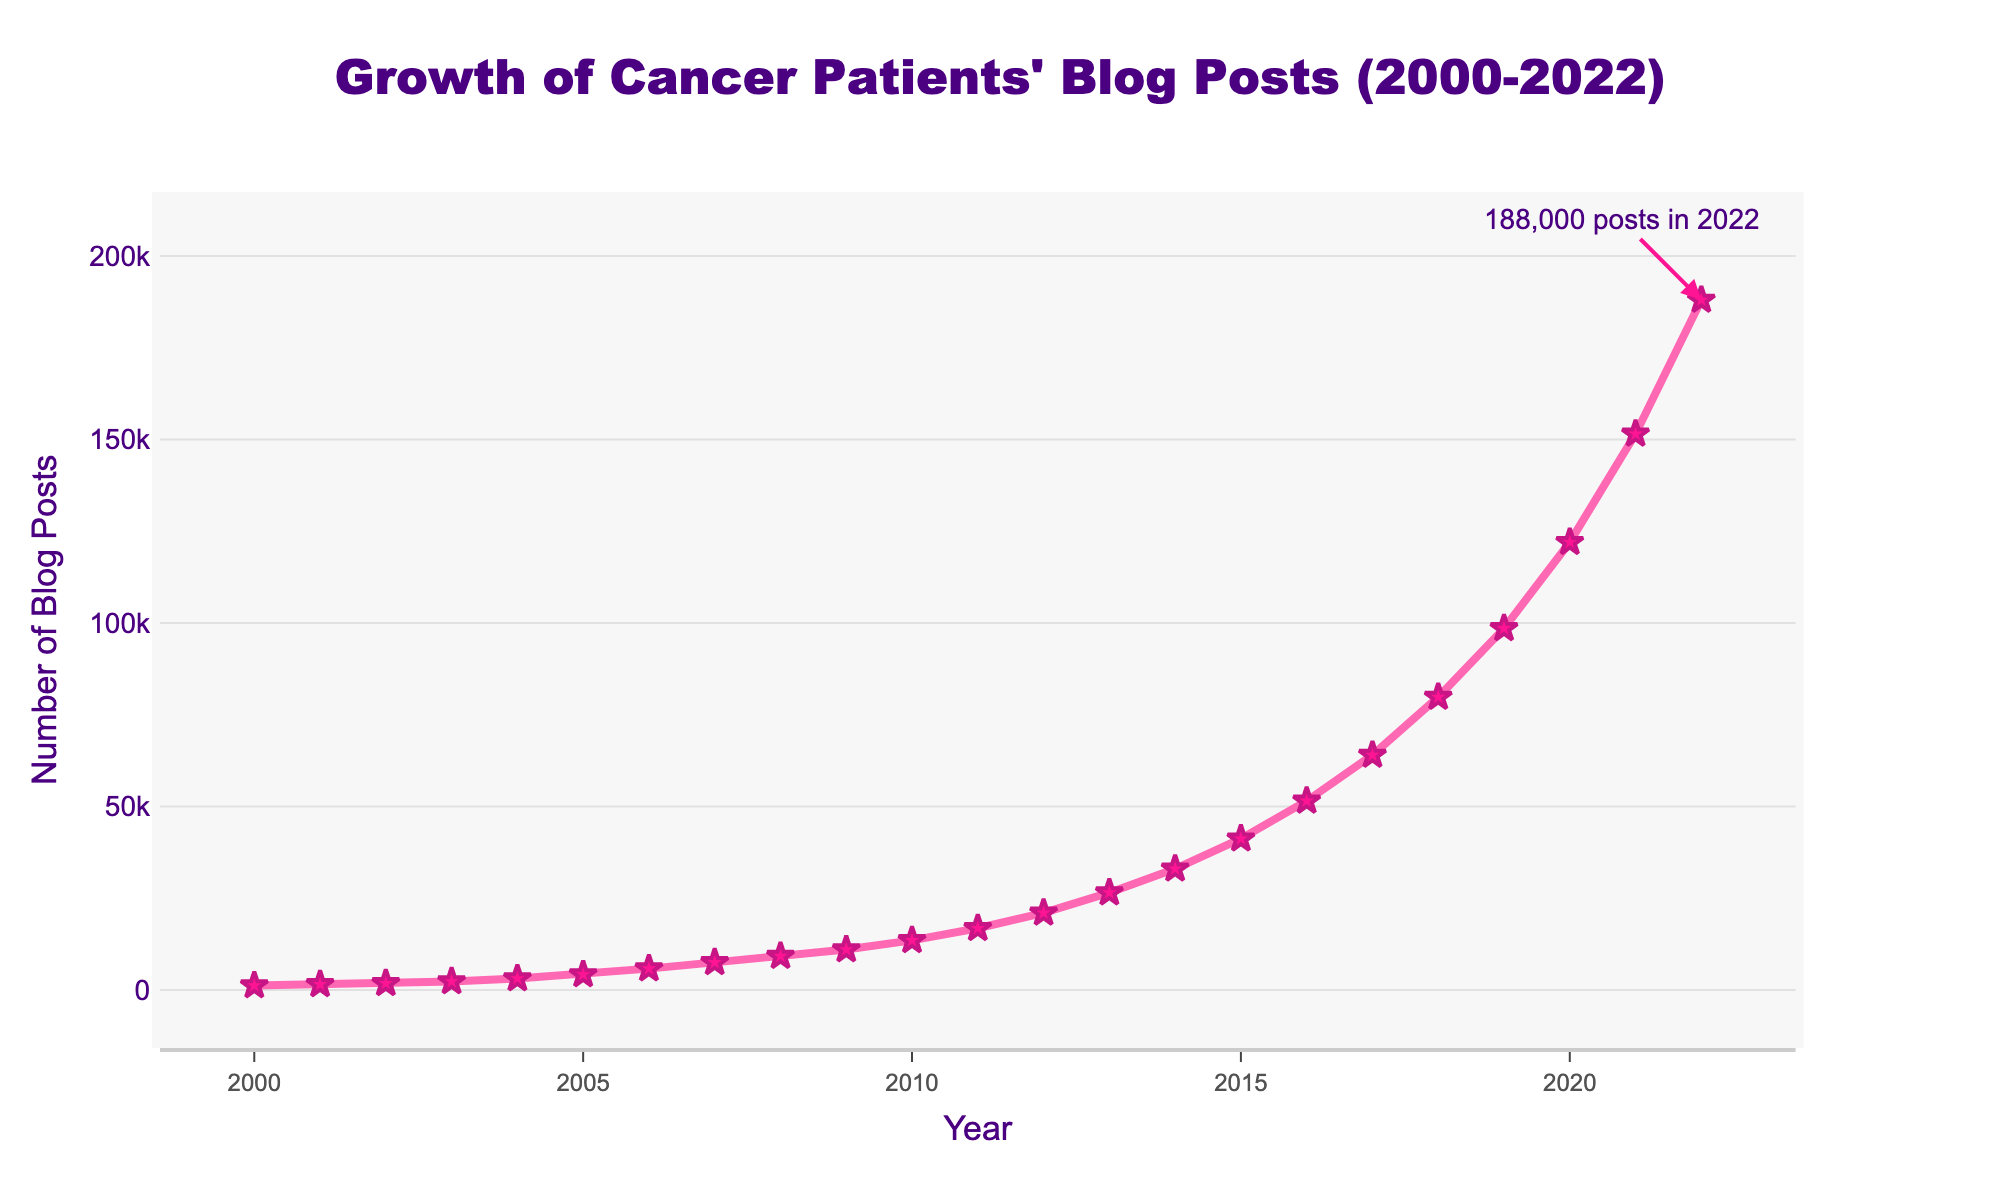What is the title of the figure? The title is usually placed at the top of the figure. It is "Growth of Cancer Patients' Blog Posts (2000-2022)".
Answer: Growth of Cancer Patients' Blog Posts (2000-2022) In which year did the number of blog posts by cancer patients first exceed 10,000? Scan through the y-axis and detect when the line crosses the 10,000 mark. This occurs in 2009.
Answer: 2009 How many blog posts were written by cancer patients in 2015? Look for the data point corresponding to the year 2015 on the x-axis. The y-axis value here is 41,200.
Answer: 41,200 What is the increase in the number of blog posts from 2000 to 2022? Determine the number of blog posts in 2022 and subtract the number of blog posts in 2000. That is, 188,000 - 1,200.
Answer: 186,800 By what factor did the number of blog posts grow from 2005 to 2015? Calculate the number of blog posts in 2015 and 2005, then divide the 2015 value by the 2005 value: 41,200 / 4,200.
Answer: 9.8 When did the number of blog posts reach approximately halfway between the initial value in 2000 and the peak in 2022? Calculate the halfway point: (188,000 + 1,200) / 2 = 94,600. The year when the line crosses this point is closest to 2019.
Answer: 2019 Which year saw the steepest increase in the number of blog posts compared to the previous year? Observe the slope of the line between adjacent years and assess the steepest climb, which occurs between 2020 and 2021.
Answer: 2020-2021 What is the visual cue indicating the maximum data point on the line chart? Identify the visual annotations or markers, such as the annotation which notes "188,000 posts in 2022".
Answer: Annotation at the top Comparing the number of blog posts in 2003 and 2013, by how much did the number of blog posts increase over these ten years? Identify the number of blog posts in 2003 (2,300) and 2013 (26,500), and calculate the difference: 26,500 - 2,300.
Answer: 24,200 